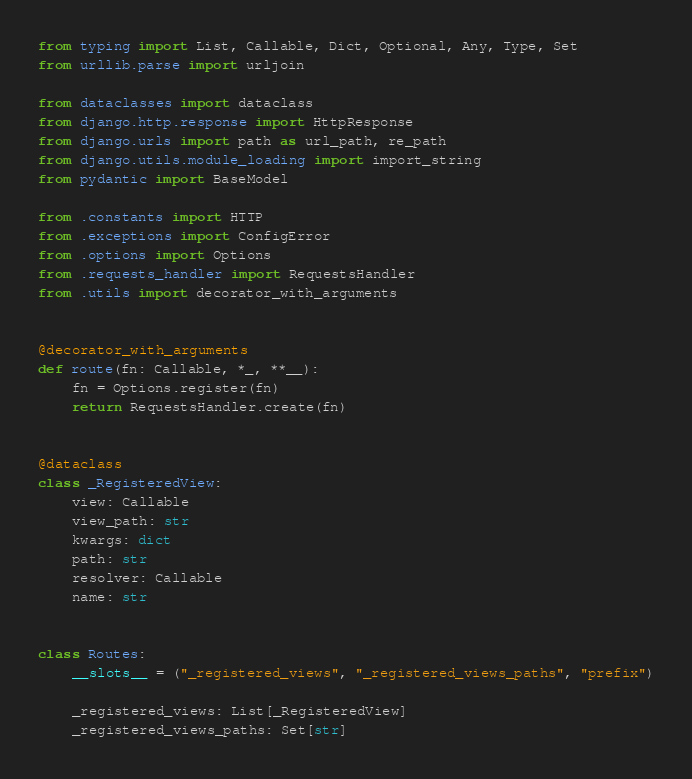<code> <loc_0><loc_0><loc_500><loc_500><_Python_>from typing import List, Callable, Dict, Optional, Any, Type, Set
from urllib.parse import urljoin

from dataclasses import dataclass
from django.http.response import HttpResponse
from django.urls import path as url_path, re_path
from django.utils.module_loading import import_string
from pydantic import BaseModel

from .constants import HTTP
from .exceptions import ConfigError
from .options import Options
from .requests_handler import RequestsHandler
from .utils import decorator_with_arguments


@decorator_with_arguments
def route(fn: Callable, *_, **__):
    fn = Options.register(fn)
    return RequestsHandler.create(fn)


@dataclass
class _RegisteredView:
    view: Callable
    view_path: str
    kwargs: dict
    path: str
    resolver: Callable
    name: str


class Routes:
    __slots__ = ("_registered_views", "_registered_views_paths", "prefix")

    _registered_views: List[_RegisteredView]
    _registered_views_paths: Set[str]
</code> 